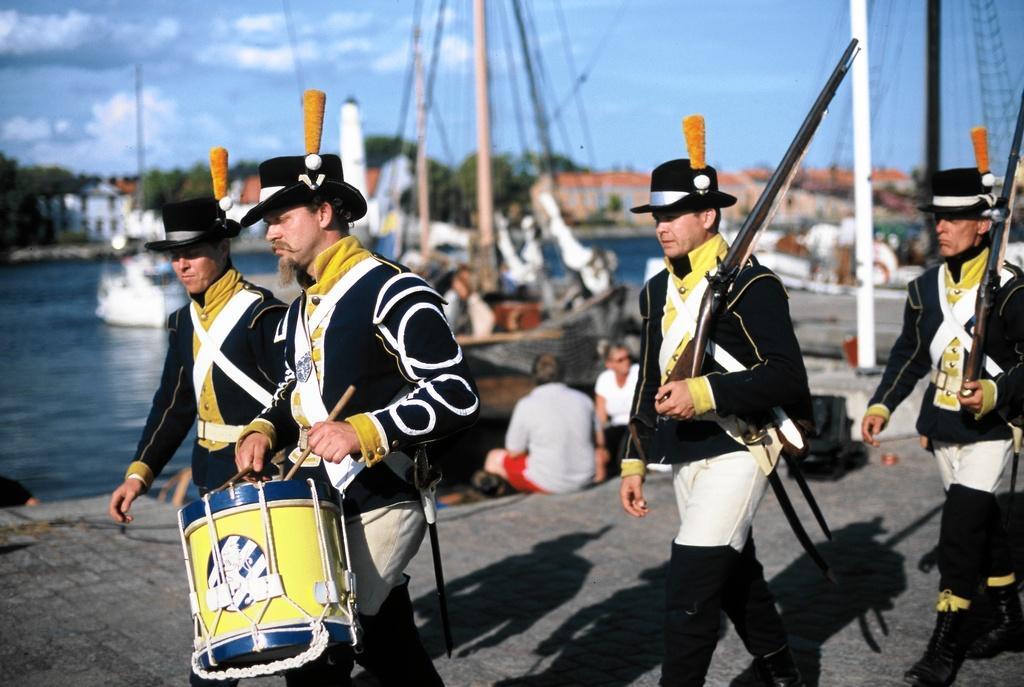In one or two sentences, can you explain what this image depicts? In this image we can see a man is playing drum with sticks in his hand, two persons are holding guns in their hands and there is another man standing. In the background we can see ships on the water, few persons are sitting on the road, trees, buildings, windows, poles and clouds in the sky. 